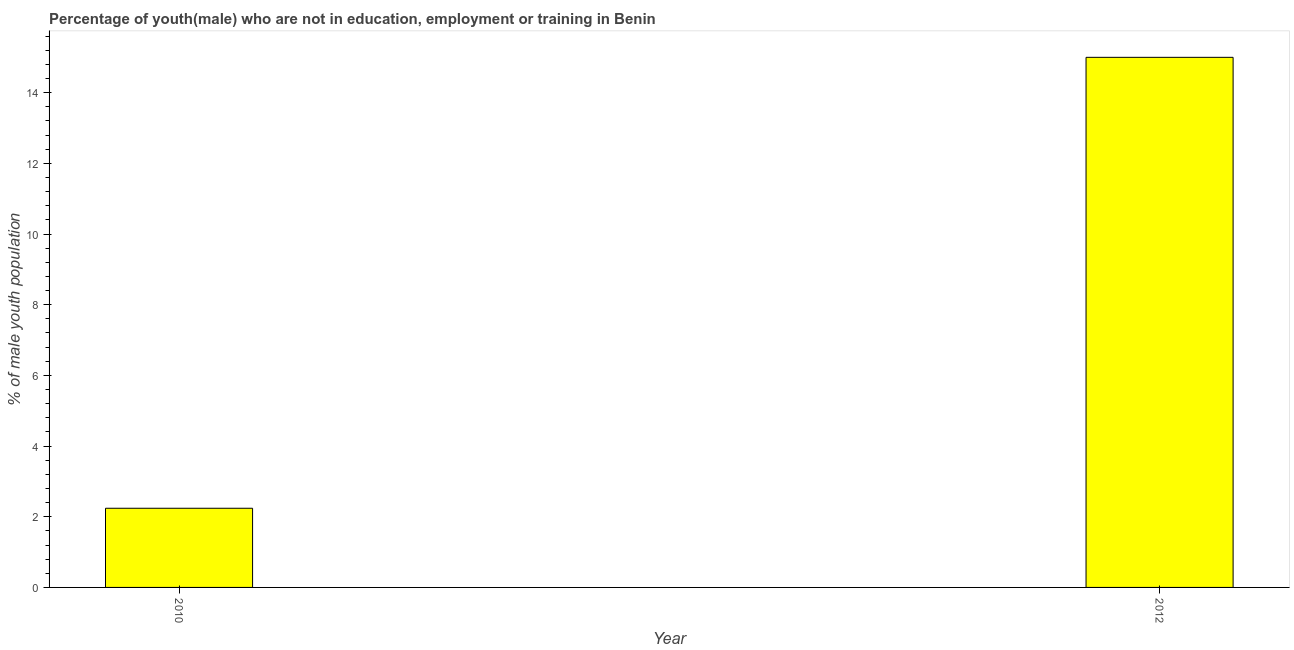Does the graph contain any zero values?
Your answer should be compact. No. Does the graph contain grids?
Make the answer very short. No. What is the title of the graph?
Your response must be concise. Percentage of youth(male) who are not in education, employment or training in Benin. What is the label or title of the X-axis?
Ensure brevity in your answer.  Year. What is the label or title of the Y-axis?
Offer a very short reply. % of male youth population. What is the unemployed male youth population in 2010?
Provide a short and direct response. 2.24. Across all years, what is the minimum unemployed male youth population?
Ensure brevity in your answer.  2.24. In which year was the unemployed male youth population minimum?
Your response must be concise. 2010. What is the sum of the unemployed male youth population?
Ensure brevity in your answer.  17.24. What is the difference between the unemployed male youth population in 2010 and 2012?
Ensure brevity in your answer.  -12.76. What is the average unemployed male youth population per year?
Offer a terse response. 8.62. What is the median unemployed male youth population?
Offer a terse response. 8.62. Do a majority of the years between 2010 and 2012 (inclusive) have unemployed male youth population greater than 12 %?
Offer a terse response. No. What is the ratio of the unemployed male youth population in 2010 to that in 2012?
Provide a succinct answer. 0.15. Is the unemployed male youth population in 2010 less than that in 2012?
Your response must be concise. Yes. What is the % of male youth population in 2010?
Keep it short and to the point. 2.24. What is the % of male youth population in 2012?
Provide a short and direct response. 15. What is the difference between the % of male youth population in 2010 and 2012?
Your response must be concise. -12.76. What is the ratio of the % of male youth population in 2010 to that in 2012?
Give a very brief answer. 0.15. 